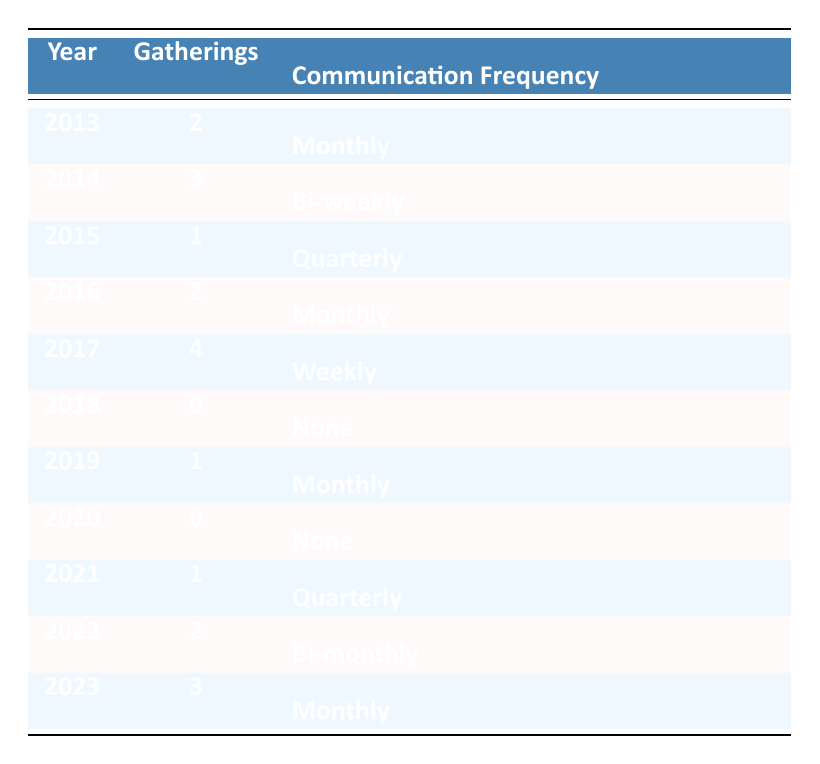What was the year with the highest number of family gatherings? By scanning the "Gatherings" column, the year with the highest count is 2017, which recorded 4 gatherings.
Answer: 2017 How many years had no family gatherings? Looking at the "Gatherings" column, the years 2018 and 2020 both show 0 gatherings. Therefore, there are 2 years with no gatherings.
Answer: 2 What is the average number of gatherings per year over the decade? To find the average, sum up all the gatherings: (2 + 3 + 1 + 2 + 4 + 0 + 1 + 0 + 1 + 2 + 3) = 19. Then, divide by the number of years (11): 19 / 11 ≈ 1.73.
Answer: Approximately 1.73 Which year had the highest communication frequency? Analyzing the "Communication Frequency" column, the year 2017 stands out with "Weekly" communication, which is the highest frequency indicated.
Answer: 2017 Is it true that the family had gatherings every year except for one? Counting the number of years with gatherings (2013, 2014, 2015, 2016, 2017, 2019, 2021, 2022, 2023), there are 9 years with gatherings and 2 years without (2018 and 2020). So the statement is false.
Answer: No In which year did the frequency of communication drop to 'None'? The "Communication Frequency" column shows 'None' for 2018 and 2020. Therefore, both years had a communication frequency of 'None'.
Answer: 2018 and 2020 What was the change in gatherings from 2016 to 2017? Comparing the gatherings for 2016 (2) and 2017 (4), there was an increase of 2 gatherings from 2016 to 2017.
Answer: Increase of 2 Which year had the second highest gatherings? The year with the second highest count is 2014, which had 3 gatherings, following 2017 which had 4 gatherings.
Answer: 2014 How did the gatherings trend over the years from 2013 to 2023? By observing the gatherings data: it increased from 2 in 2013 to 4 in 2017, then dropped to 0 in 2018 and 2020, and slightly increased to 3 in 2023. Overall, the trend shows fluctuation but peaks in 2017.
Answer: Fluctuating with a peak in 2017 